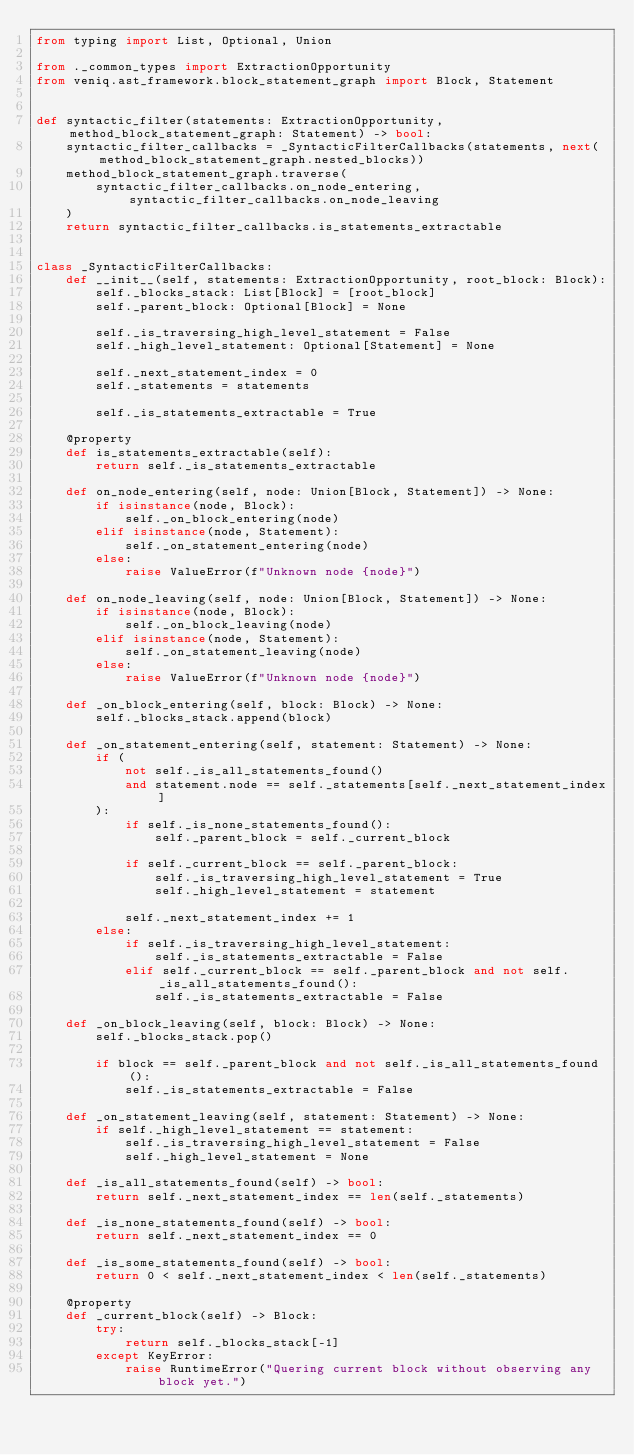Convert code to text. <code><loc_0><loc_0><loc_500><loc_500><_Python_>from typing import List, Optional, Union

from ._common_types import ExtractionOpportunity
from veniq.ast_framework.block_statement_graph import Block, Statement


def syntactic_filter(statements: ExtractionOpportunity, method_block_statement_graph: Statement) -> bool:
    syntactic_filter_callbacks = _SyntacticFilterCallbacks(statements, next(method_block_statement_graph.nested_blocks))
    method_block_statement_graph.traverse(
        syntactic_filter_callbacks.on_node_entering, syntactic_filter_callbacks.on_node_leaving
    )
    return syntactic_filter_callbacks.is_statements_extractable


class _SyntacticFilterCallbacks:
    def __init__(self, statements: ExtractionOpportunity, root_block: Block):
        self._blocks_stack: List[Block] = [root_block]
        self._parent_block: Optional[Block] = None

        self._is_traversing_high_level_statement = False
        self._high_level_statement: Optional[Statement] = None

        self._next_statement_index = 0
        self._statements = statements

        self._is_statements_extractable = True

    @property
    def is_statements_extractable(self):
        return self._is_statements_extractable

    def on_node_entering(self, node: Union[Block, Statement]) -> None:
        if isinstance(node, Block):
            self._on_block_entering(node)
        elif isinstance(node, Statement):
            self._on_statement_entering(node)
        else:
            raise ValueError(f"Unknown node {node}")

    def on_node_leaving(self, node: Union[Block, Statement]) -> None:
        if isinstance(node, Block):
            self._on_block_leaving(node)
        elif isinstance(node, Statement):
            self._on_statement_leaving(node)
        else:
            raise ValueError(f"Unknown node {node}")

    def _on_block_entering(self, block: Block) -> None:
        self._blocks_stack.append(block)

    def _on_statement_entering(self, statement: Statement) -> None:
        if (
            not self._is_all_statements_found()
            and statement.node == self._statements[self._next_statement_index]
        ):
            if self._is_none_statements_found():
                self._parent_block = self._current_block

            if self._current_block == self._parent_block:
                self._is_traversing_high_level_statement = True
                self._high_level_statement = statement

            self._next_statement_index += 1
        else:
            if self._is_traversing_high_level_statement:
                self._is_statements_extractable = False
            elif self._current_block == self._parent_block and not self._is_all_statements_found():
                self._is_statements_extractable = False

    def _on_block_leaving(self, block: Block) -> None:
        self._blocks_stack.pop()

        if block == self._parent_block and not self._is_all_statements_found():
            self._is_statements_extractable = False

    def _on_statement_leaving(self, statement: Statement) -> None:
        if self._high_level_statement == statement:
            self._is_traversing_high_level_statement = False
            self._high_level_statement = None

    def _is_all_statements_found(self) -> bool:
        return self._next_statement_index == len(self._statements)

    def _is_none_statements_found(self) -> bool:
        return self._next_statement_index == 0

    def _is_some_statements_found(self) -> bool:
        return 0 < self._next_statement_index < len(self._statements)

    @property
    def _current_block(self) -> Block:
        try:
            return self._blocks_stack[-1]
        except KeyError:
            raise RuntimeError("Quering current block without observing any block yet.")
</code> 